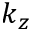<formula> <loc_0><loc_0><loc_500><loc_500>k _ { z }</formula> 